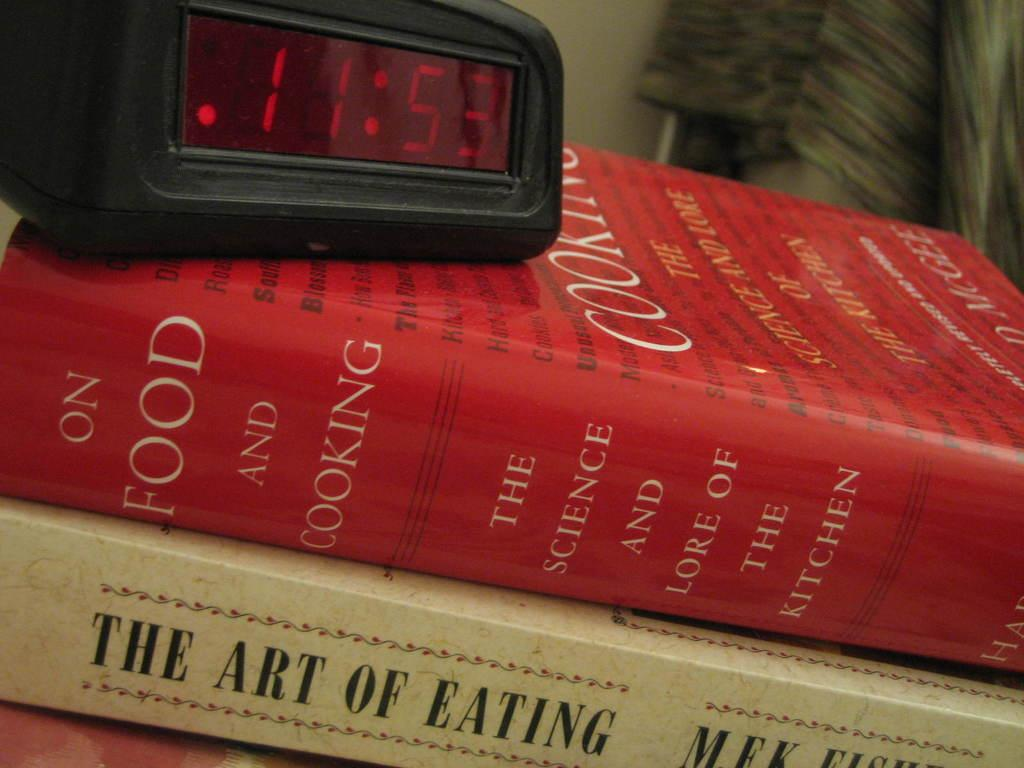<image>
Give a short and clear explanation of the subsequent image. Red book that is titled The Science and Lore of the Kitchen 